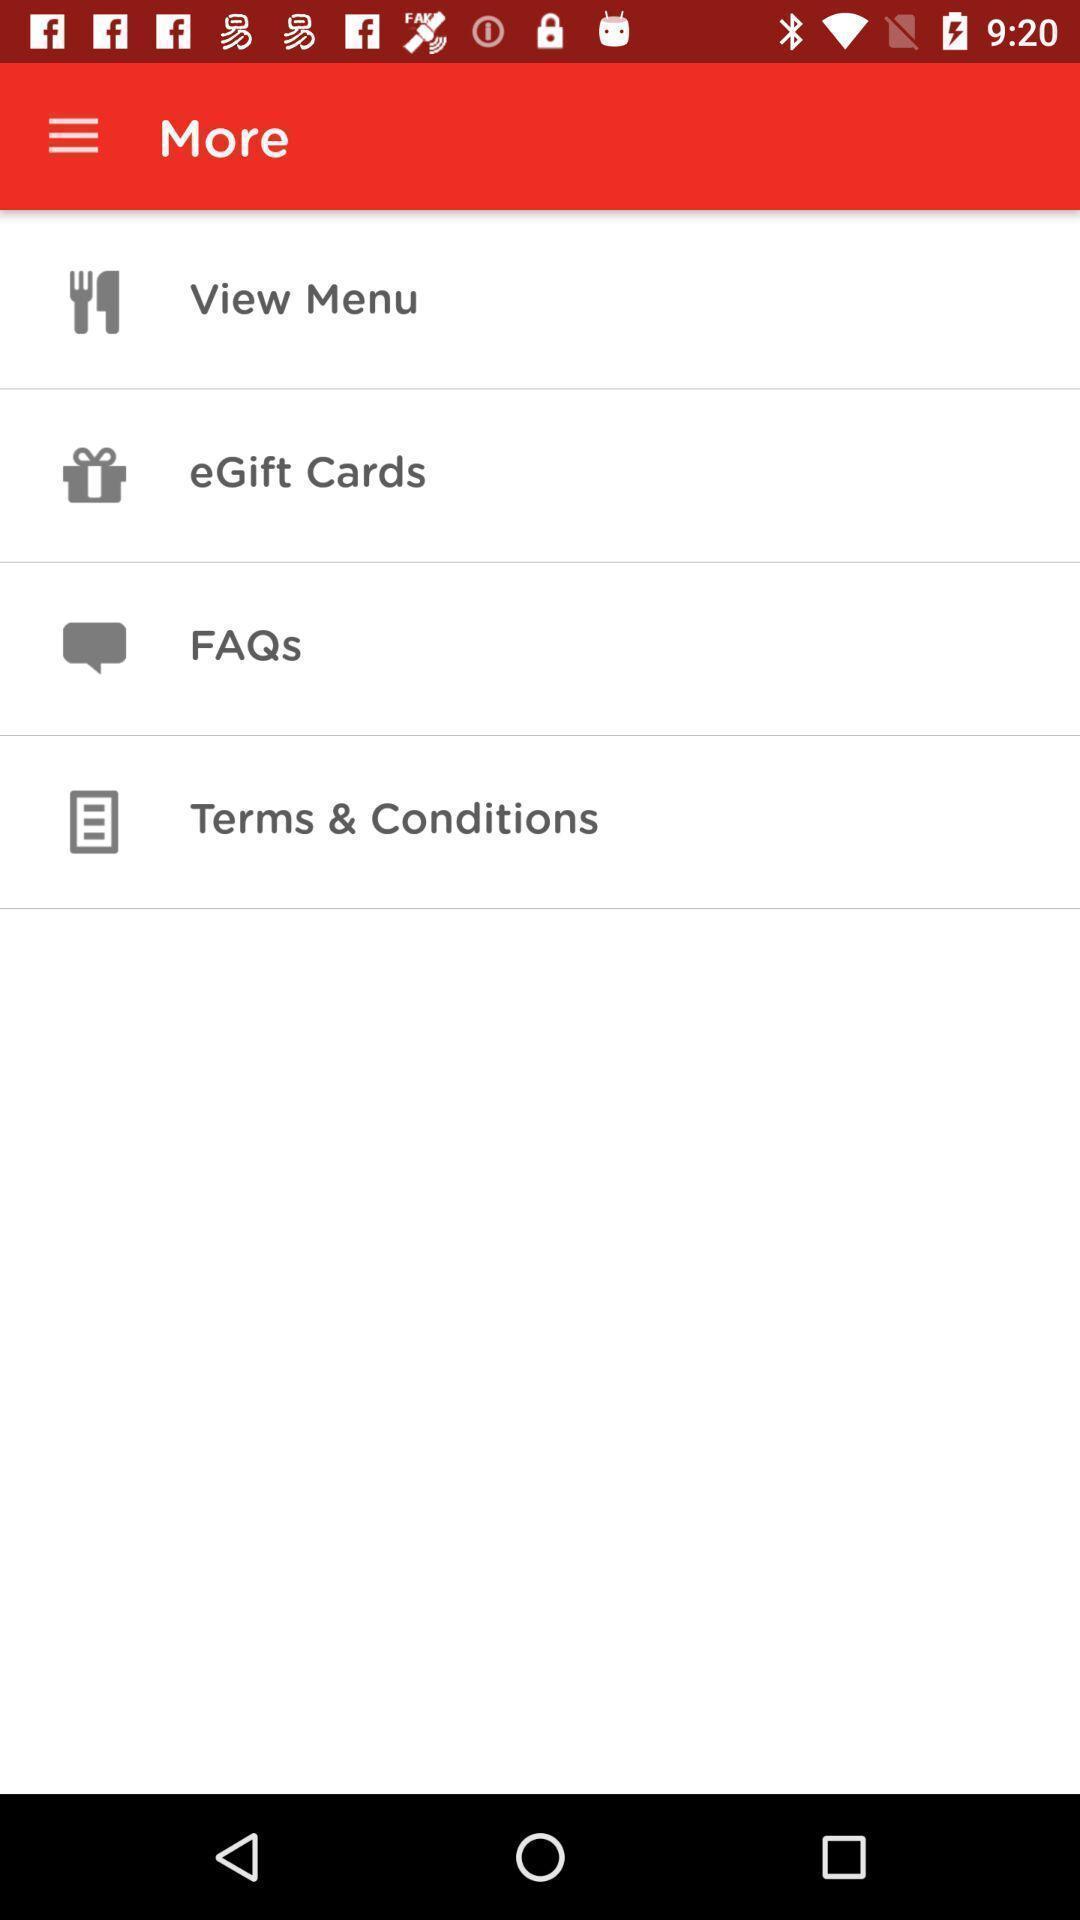Provide a textual representation of this image. Page showing different options under more on an app. 